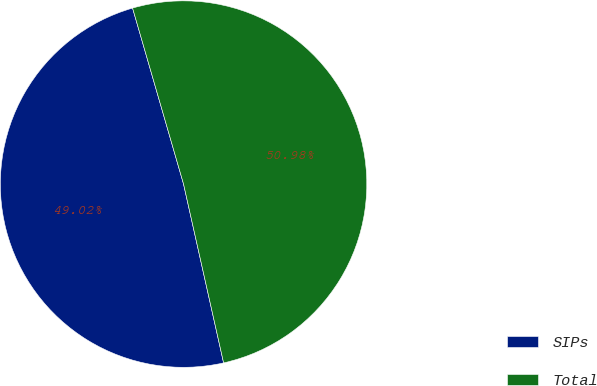<chart> <loc_0><loc_0><loc_500><loc_500><pie_chart><fcel>SIPs<fcel>Total<nl><fcel>49.02%<fcel>50.98%<nl></chart> 